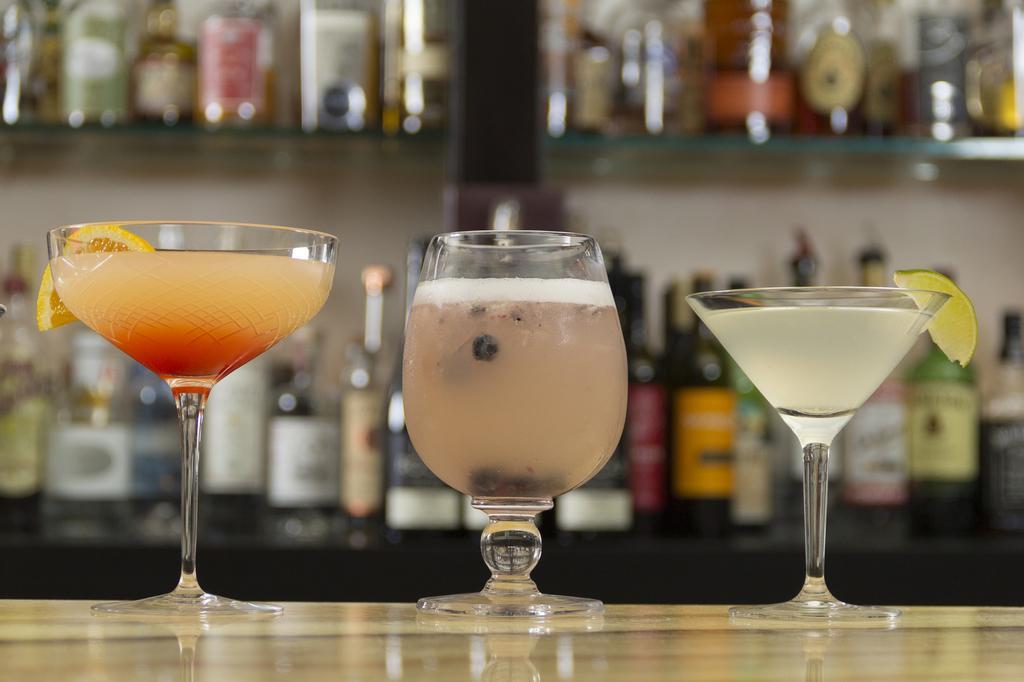Can you describe this image briefly? At the bottom of the image we can see a table. On the table we can see the glasses which contains liquids with lemon slices. In the background of the image we can see the wall, shelves. In shelves we can see the wine bottles. 